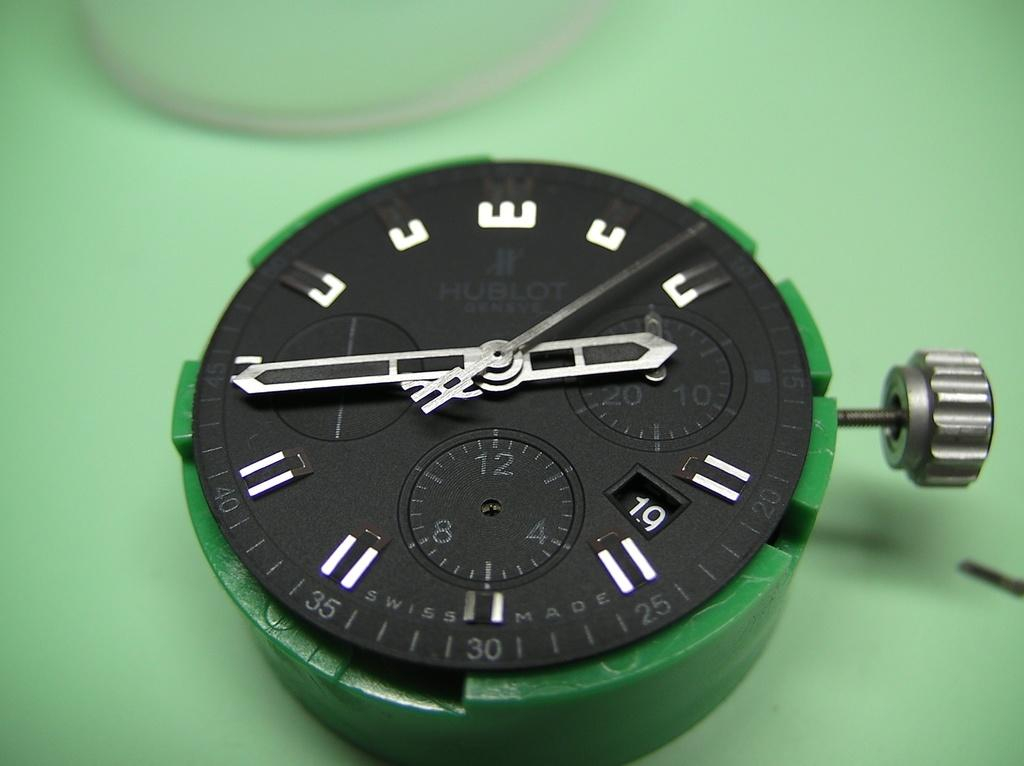<image>
Relay a brief, clear account of the picture shown. A green and black watch with the number 19 displayed. 